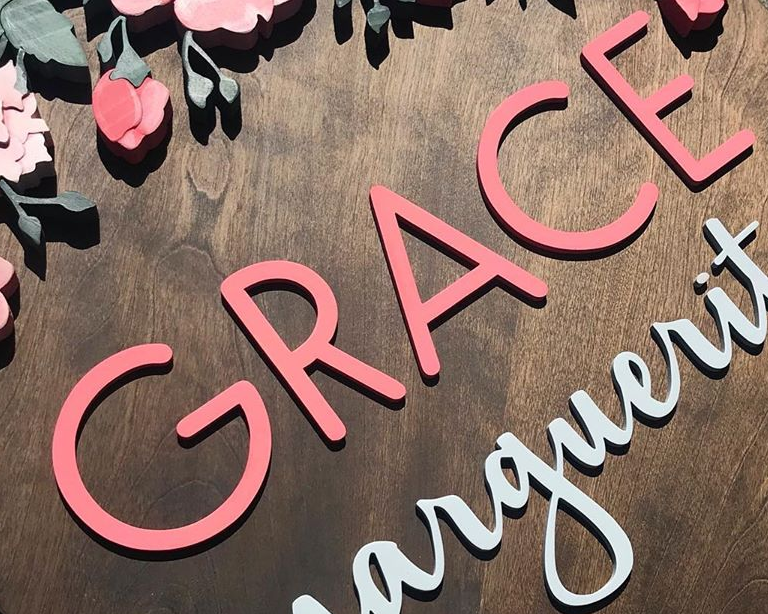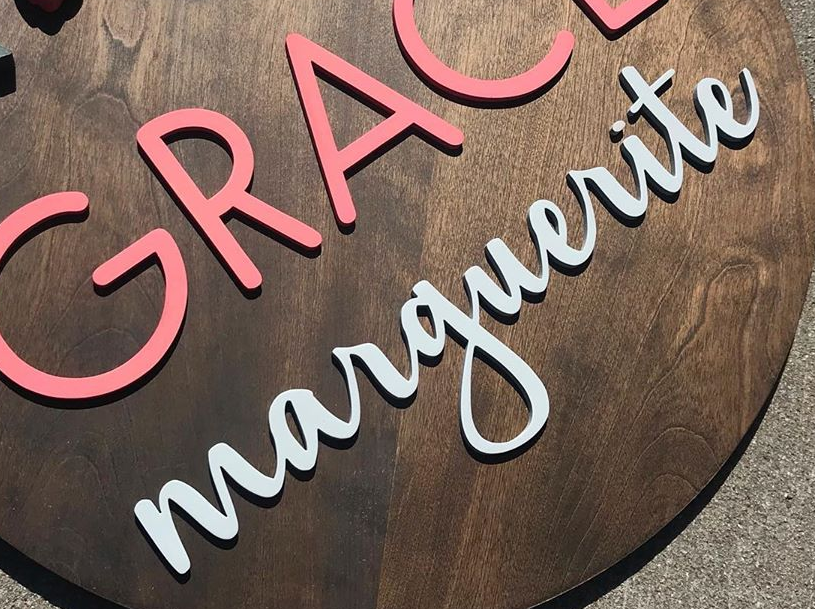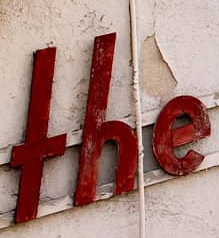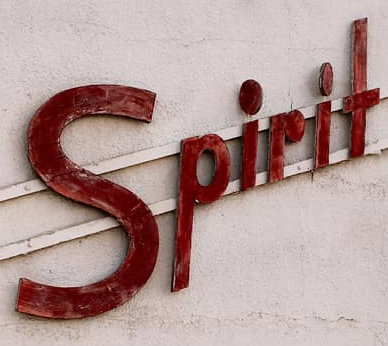What words can you see in these images in sequence, separated by a semicolon? GRACE; marguerite; THE; Spirit 